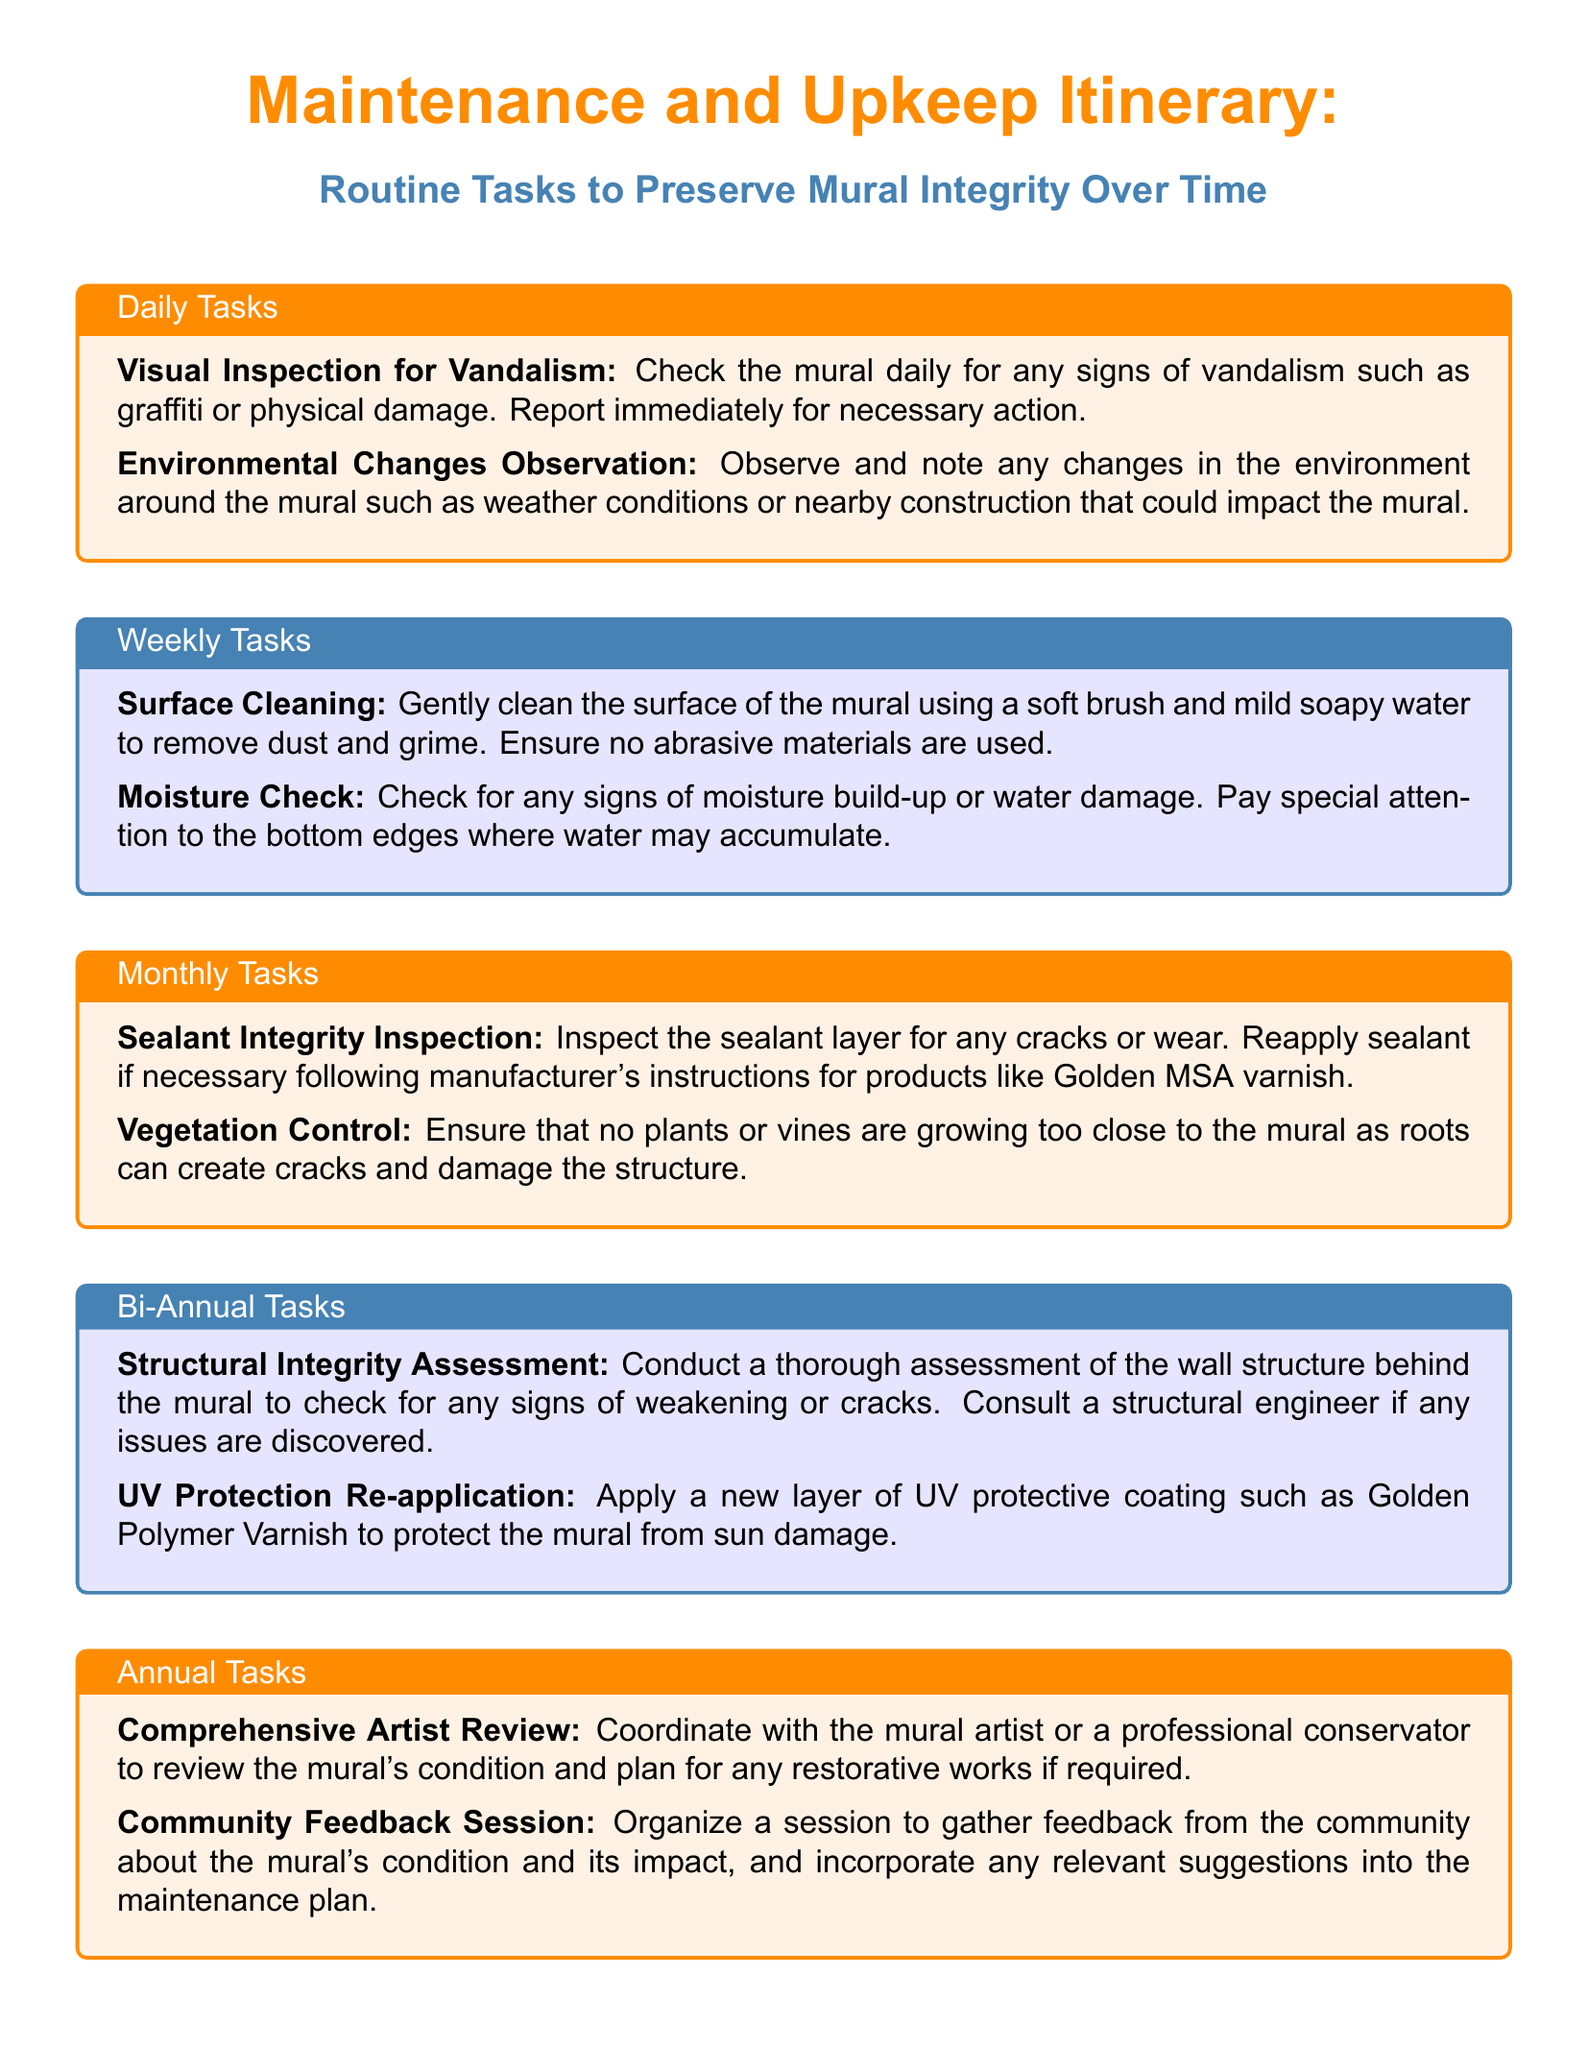What are the daily tasks? The daily tasks are listed under the "Daily Tasks" section in the document.
Answer: Visual Inspection for Vandalism, Environmental Changes Observation How often should the sealant be inspected? The sealant should be inspected in the "Monthly Tasks" section, which indicates it is a monthly activity.
Answer: Monthly What coating is applied for UV protection? The document specifies a type of coating used for UV protection in the "Bi-Annual Tasks" section.
Answer: Golden Polymer Varnish What is checked during the moisture check? The moisture check task in the "Weekly Tasks" section indicates what to look for specifically.
Answer: Signs of moisture build-up or water damage How many times a year is a Comprehensive Artist Review conducted? This task is mentioned in the "Annual Tasks" section, indicating its frequency.
Answer: Once a year 